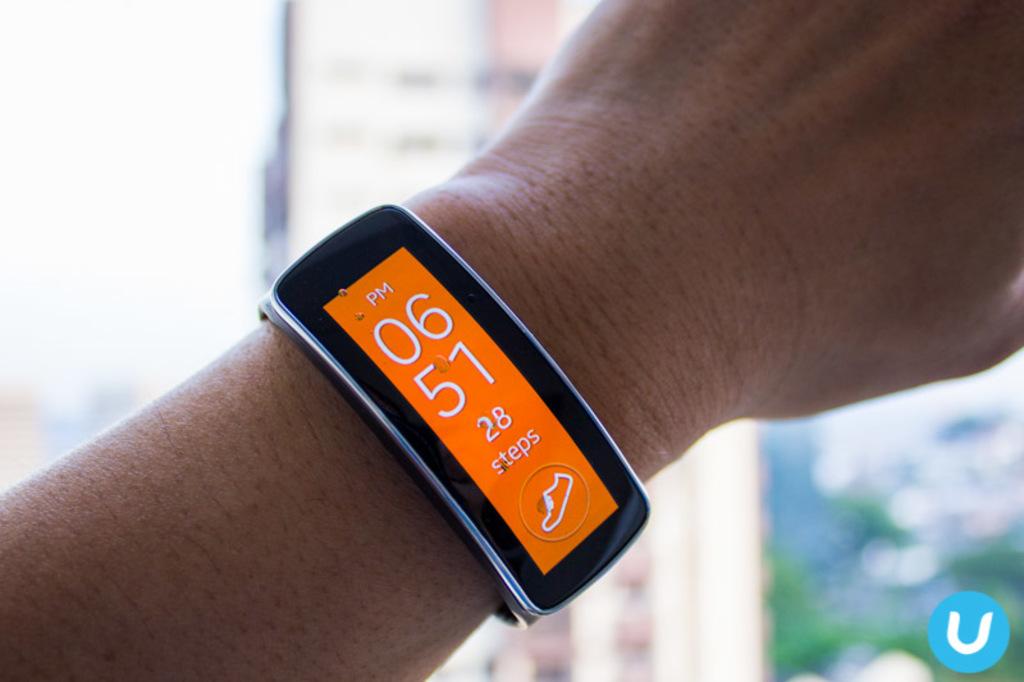How many steps have they taken?
Provide a succinct answer. 28. 